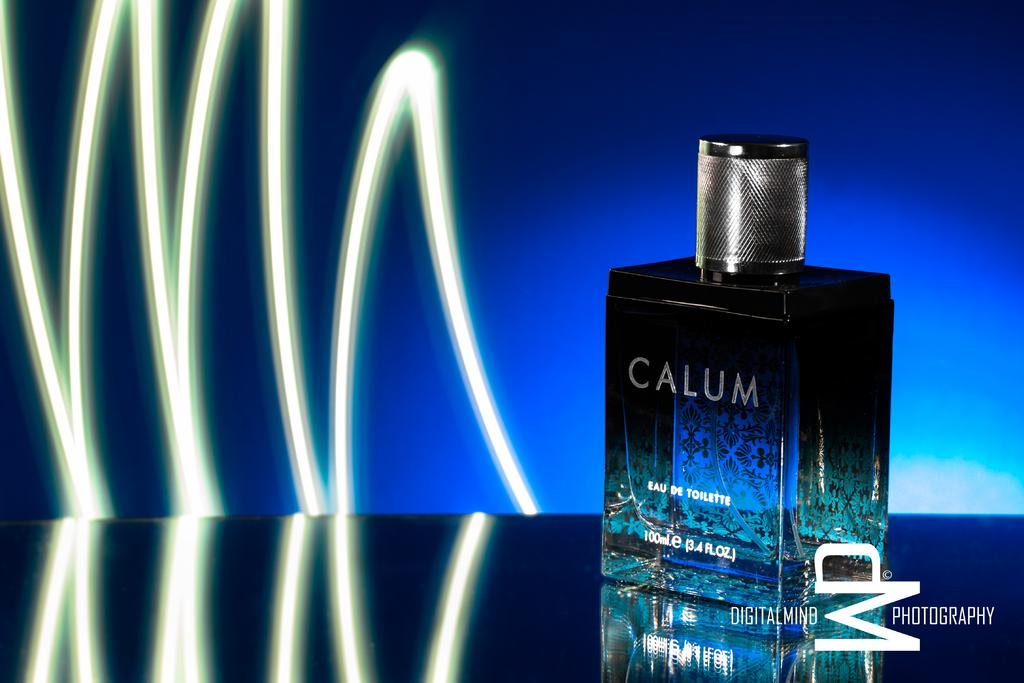<image>
Present a compact description of the photo's key features. A bottle of Calum Eau de Toillette with a neon squiggle in the back. 